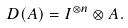Convert formula to latex. <formula><loc_0><loc_0><loc_500><loc_500>D ( A ) = I ^ { \otimes n } \otimes A .</formula> 